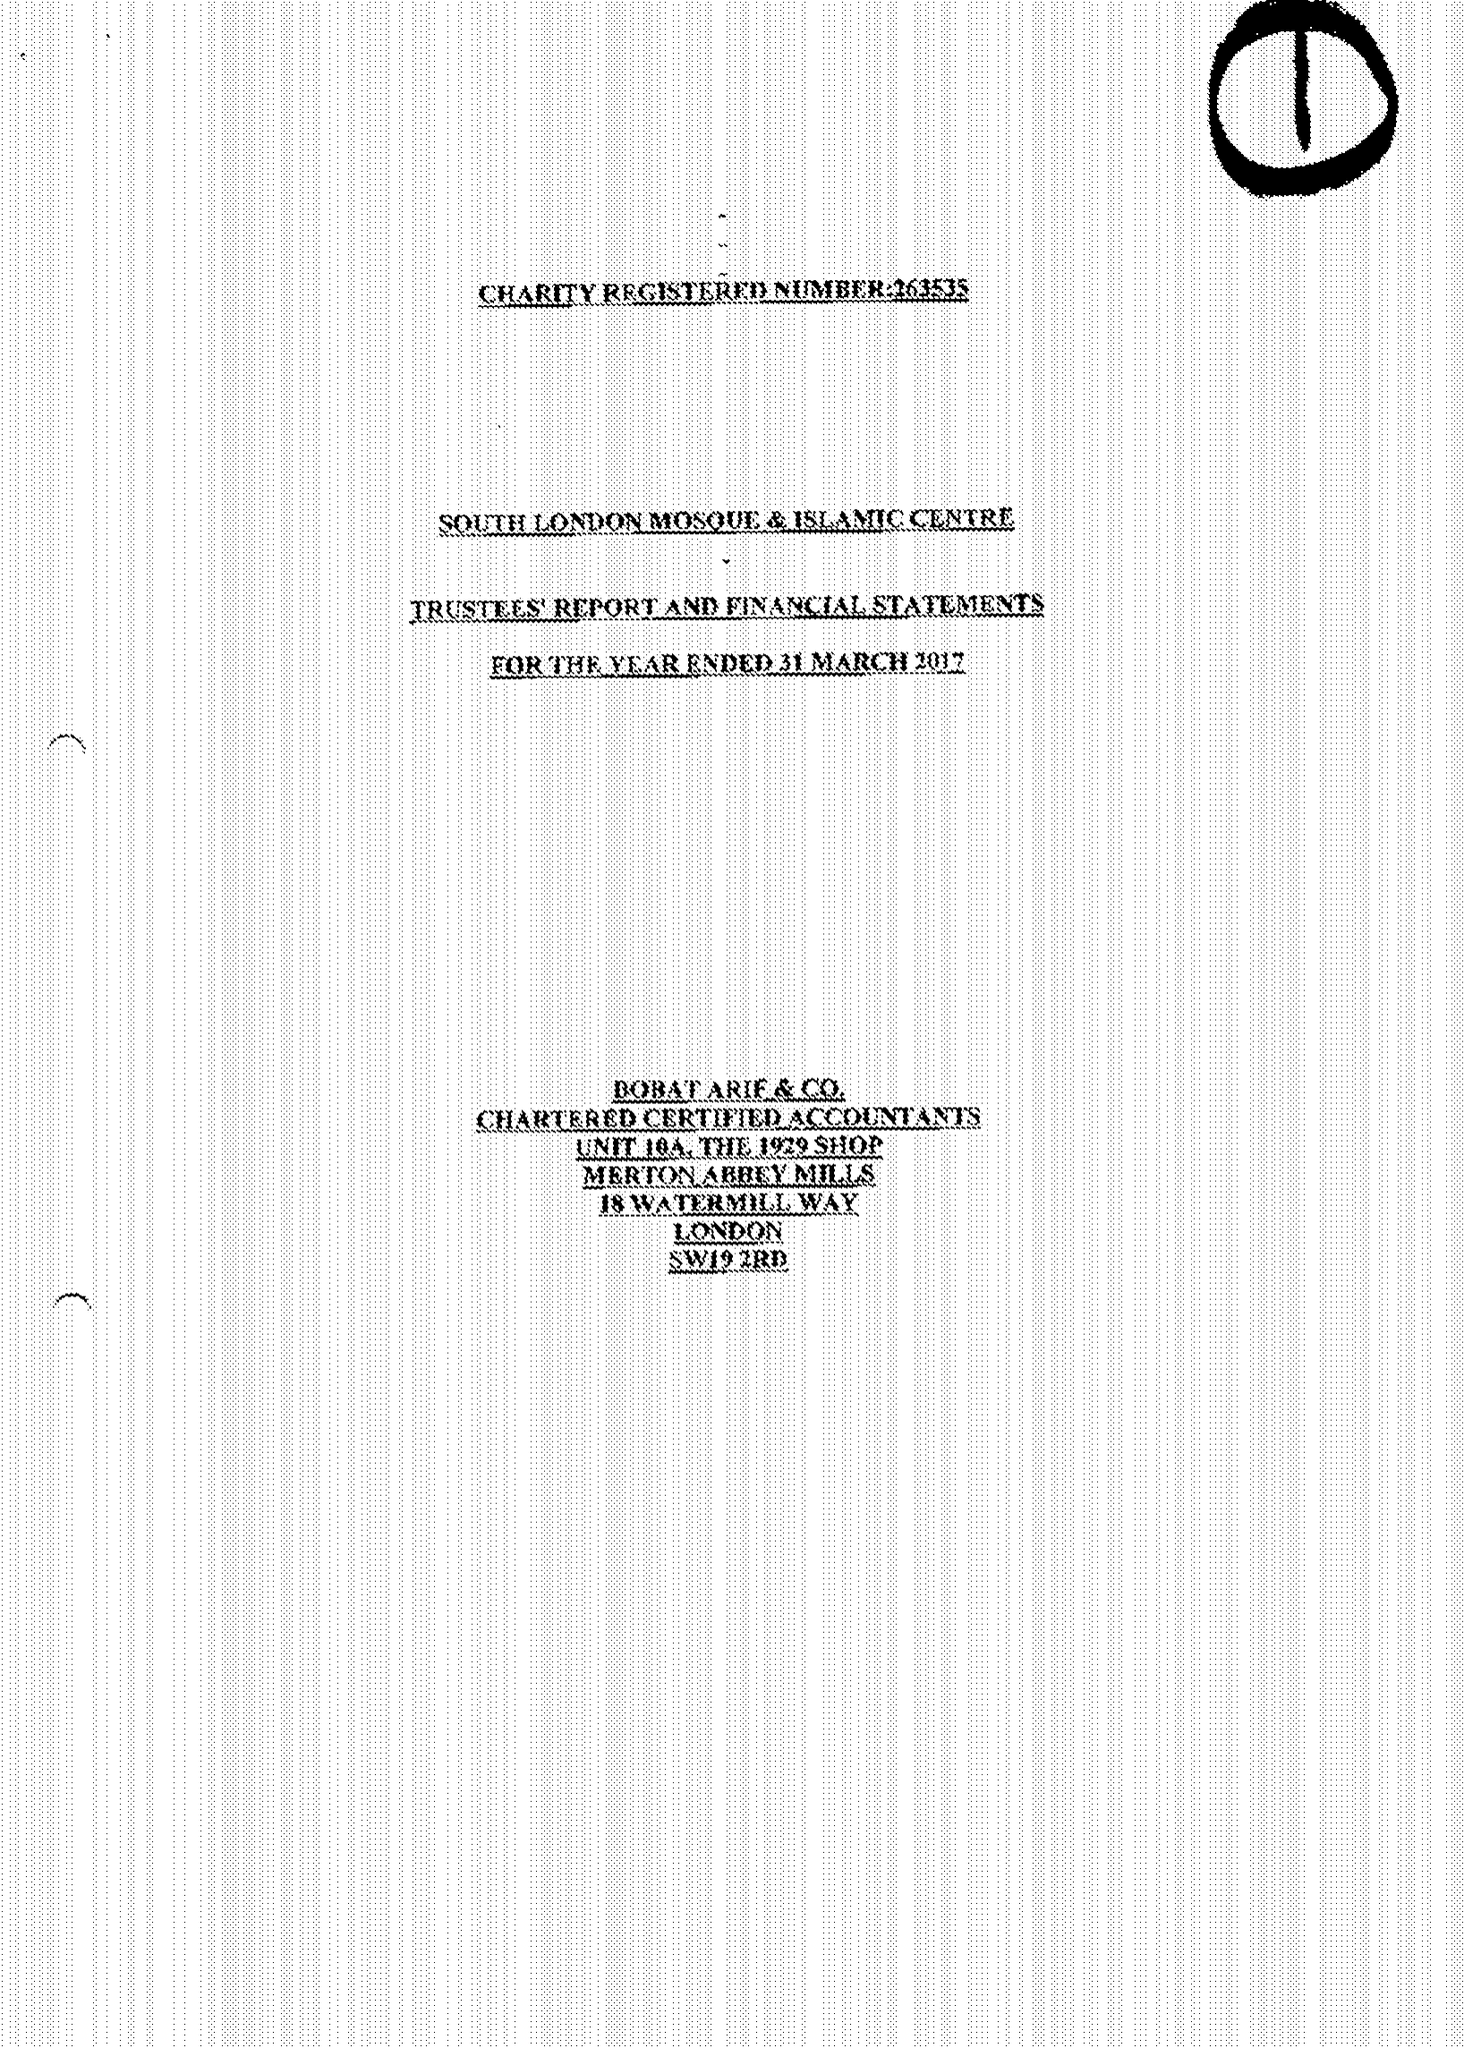What is the value for the income_annually_in_british_pounds?
Answer the question using a single word or phrase. 389998.00 